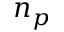Convert formula to latex. <formula><loc_0><loc_0><loc_500><loc_500>n _ { p }</formula> 